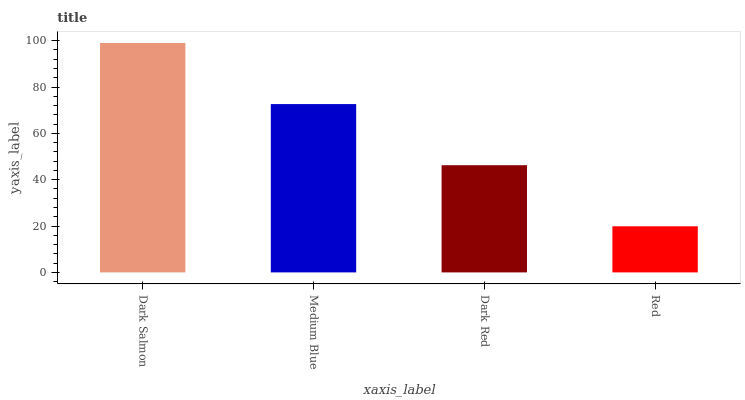Is Red the minimum?
Answer yes or no. Yes. Is Dark Salmon the maximum?
Answer yes or no. Yes. Is Medium Blue the minimum?
Answer yes or no. No. Is Medium Blue the maximum?
Answer yes or no. No. Is Dark Salmon greater than Medium Blue?
Answer yes or no. Yes. Is Medium Blue less than Dark Salmon?
Answer yes or no. Yes. Is Medium Blue greater than Dark Salmon?
Answer yes or no. No. Is Dark Salmon less than Medium Blue?
Answer yes or no. No. Is Medium Blue the high median?
Answer yes or no. Yes. Is Dark Red the low median?
Answer yes or no. Yes. Is Dark Red the high median?
Answer yes or no. No. Is Red the low median?
Answer yes or no. No. 